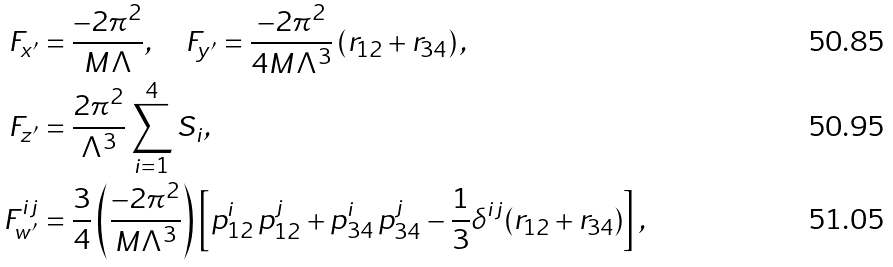Convert formula to latex. <formula><loc_0><loc_0><loc_500><loc_500>F _ { x ^ { \prime } } & = \frac { - 2 \pi ^ { 2 } } { M \Lambda } , \quad F _ { y ^ { \prime } } = \frac { - 2 \pi ^ { 2 } } { 4 M \Lambda ^ { 3 } } \left ( r _ { 1 2 } + r _ { 3 4 } \right ) , \\ F _ { z ^ { \prime } } & = \frac { 2 \pi ^ { 2 } } { \Lambda ^ { 3 } } \sum _ { i = 1 } ^ { 4 } S _ { i } , \\ { F } ^ { i j } _ { w ^ { \prime } } & = \frac { 3 } { 4 } \left ( \frac { - 2 \pi ^ { 2 } } { M \Lambda ^ { 3 } } \right ) \left [ p _ { 1 2 } ^ { i } \, p _ { 1 2 } ^ { j } + p _ { 3 4 } ^ { i } \, p _ { 3 4 } ^ { j } - \frac { 1 } { 3 } \delta ^ { i j } ( r _ { 1 2 } + r _ { 3 4 } ) \right ] ,</formula> 